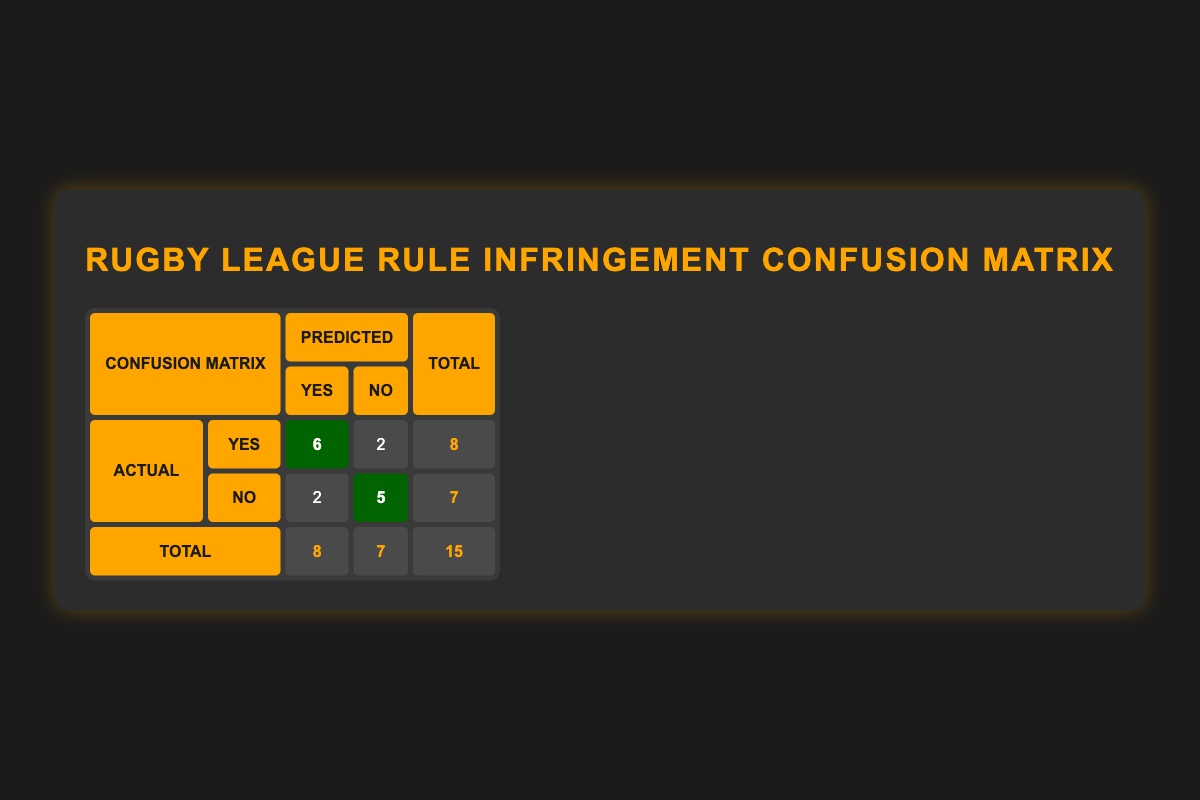What is the total number of "yes" actual calls in the confusion matrix? From the table, the total number of "yes" actual calls is the sum of the "yes" values in the first row of the "Actual" section, which is 6 (for predicted "yes") + 2 (for predicted "no"). Therefore, the total is 8.
Answer: 8 How many rule infringement calls were incorrectly predicted as "yes"? The incorrectly predicted "yes" calls are those for which the actual value is "no". From the second row under the first column of the actual calls, we see there are 2 "no" actual calls predicted as "yes" (one for high tackle and another for high contact).
Answer: 2 What is the total number of "no" predicted calls in the confusion matrix? To find this, we should look at the second column of the "Predicted" section. The total number of "no" predicted calls is the sum of the values in that column: 2 (for actual "yes") + 5 (for actual "no"), which equals 7.
Answer: 7 How many total rule infringement calls were made in the match? The total rule infringement calls are the sum of all values in the table, which is 15 (8 "yes" actual + 7 "no" actual). Counting all the predicted calls also gives the same total of 15, as per the totals at the bottom of the table.
Answer: 15 Was there any rule infringement call that had actual "yes" and was incorrectly predicted as "no"? Yes, there is one call where the actual was "yes" (professional foul) but it was predicted as "no", indicating a prediction error.
Answer: Yes What is the difference between the total actual "yes" calls and total actual "no" calls? The total actual "yes" calls are 8, and the total actual "no" calls are 7, so we subtract the total actual "no" from the total actual "yes": 8 - 7 = 1.
Answer: 1 How many actual calls were correctly predicted as "yes"? Based on the table, there are 6 actual calls that are "yes" and were predicted correctly as "yes". This is found in the first row of the confusion matrix.
Answer: 6 What percentage of total calls were predicted correctly? To calculate the percentage of calls that were predicted correctly, we consider both the actual "yes" and "no" that were correctly predicted: 6 (true positives) + 5 (true negatives) = 11. Now, we divide this by the total calls (15) and multiply by 100. So, (11/15) * 100 = 73.33%.
Answer: 73.33% 